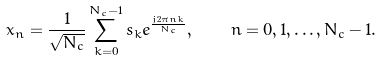<formula> <loc_0><loc_0><loc_500><loc_500>x _ { n } = \frac { 1 } { \sqrt { N _ { c } } } \sum _ { k = 0 } ^ { N _ { c } - 1 } s _ { k } e ^ { \frac { j 2 \pi n k } { N _ { c } } } , \quad n = 0 , 1 , \dots , N _ { c } - 1 .</formula> 